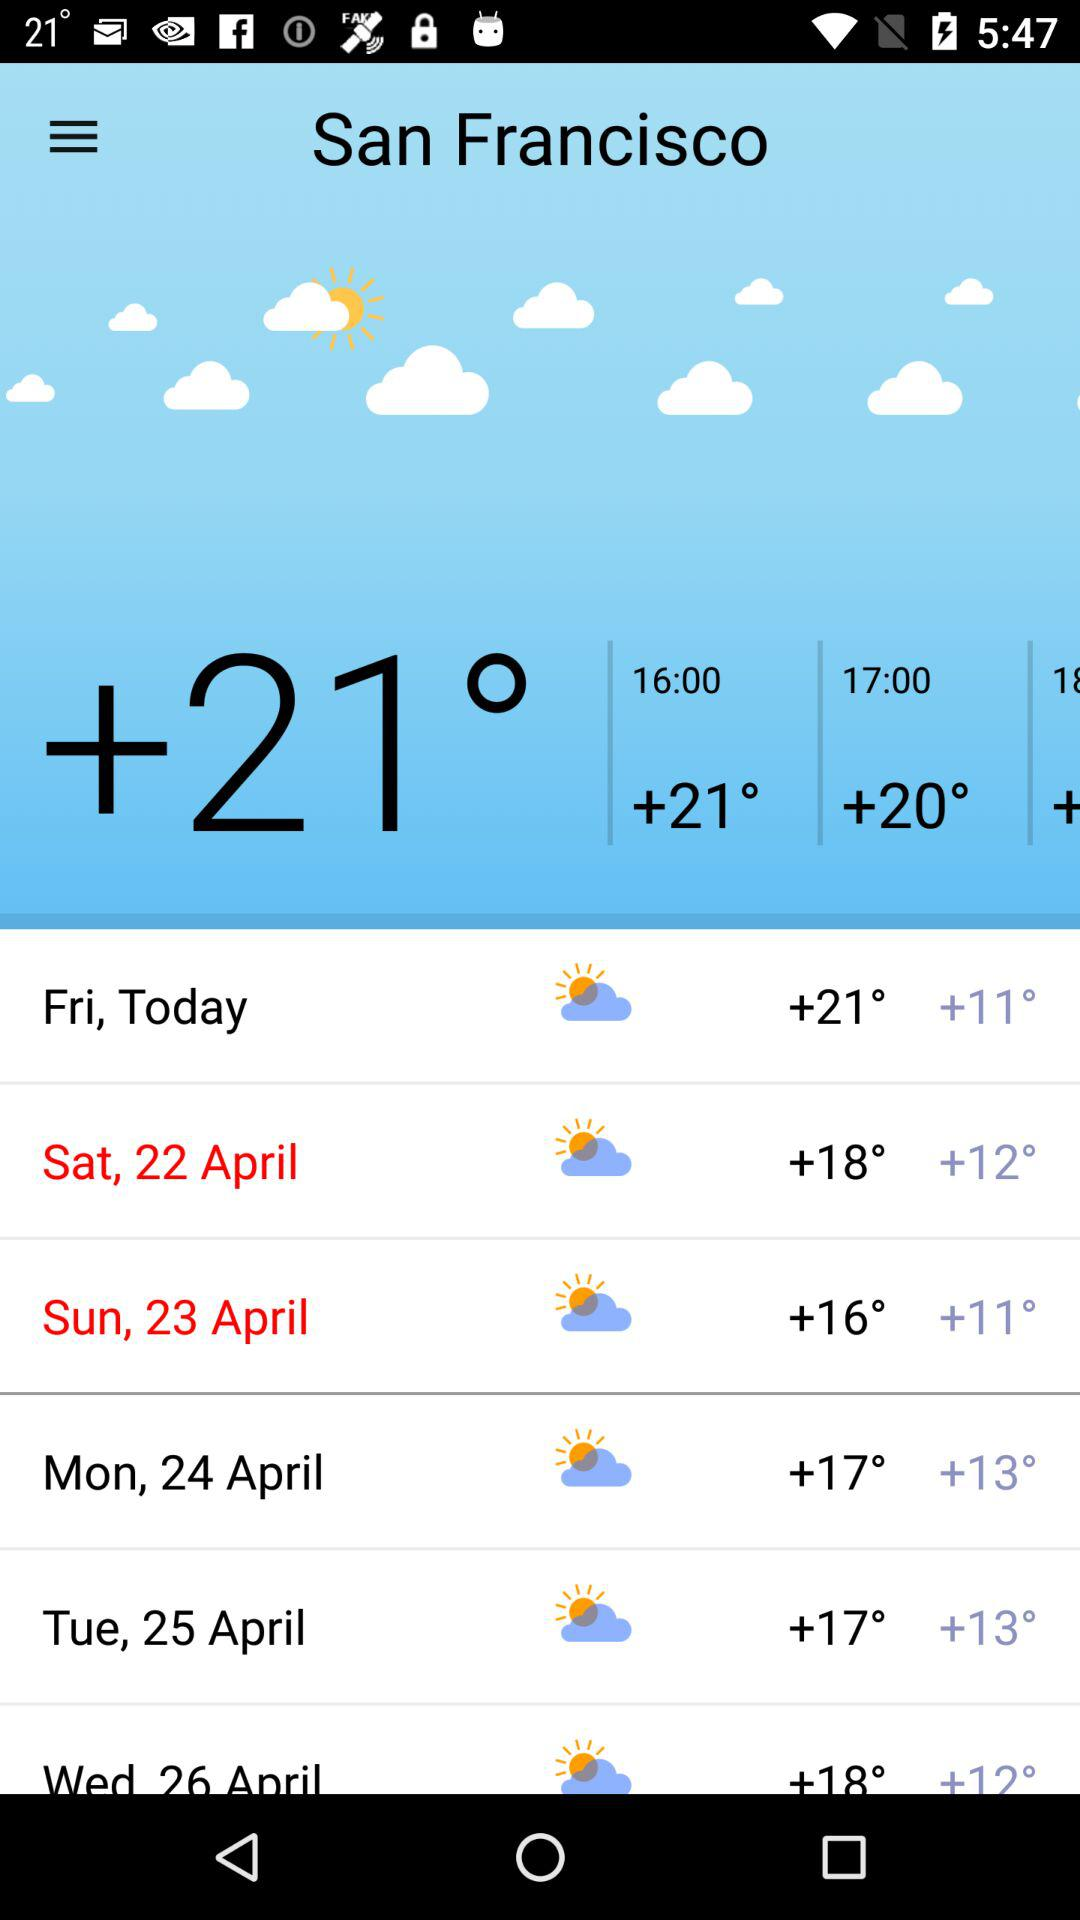What is the difference between the highest and lowest temperatures for the week?
Answer the question using a single word or phrase. 10° 